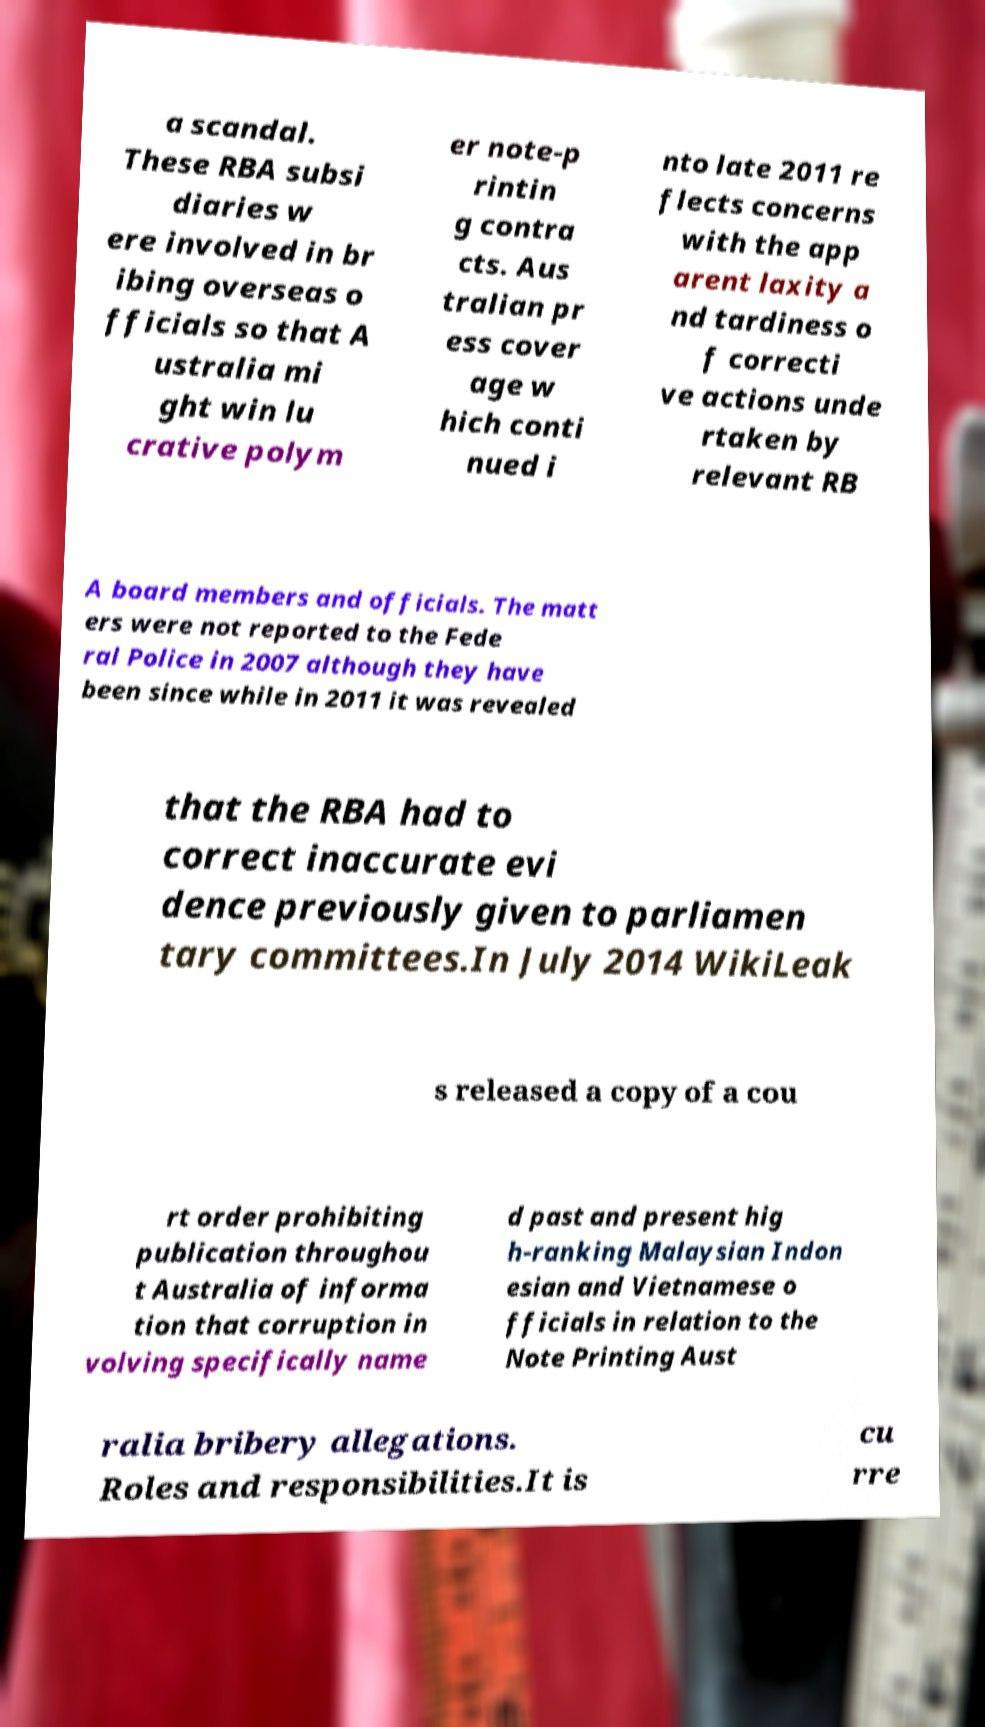Could you extract and type out the text from this image? a scandal. These RBA subsi diaries w ere involved in br ibing overseas o fficials so that A ustralia mi ght win lu crative polym er note-p rintin g contra cts. Aus tralian pr ess cover age w hich conti nued i nto late 2011 re flects concerns with the app arent laxity a nd tardiness o f correcti ve actions unde rtaken by relevant RB A board members and officials. The matt ers were not reported to the Fede ral Police in 2007 although they have been since while in 2011 it was revealed that the RBA had to correct inaccurate evi dence previously given to parliamen tary committees.In July 2014 WikiLeak s released a copy of a cou rt order prohibiting publication throughou t Australia of informa tion that corruption in volving specifically name d past and present hig h-ranking Malaysian Indon esian and Vietnamese o fficials in relation to the Note Printing Aust ralia bribery allegations. Roles and responsibilities.It is cu rre 